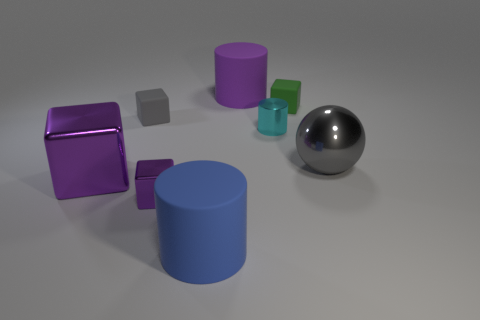Are there any small rubber balls of the same color as the metal cylinder?
Offer a very short reply. No. Are there an equal number of gray rubber things left of the large block and tiny purple things right of the big blue cylinder?
Provide a short and direct response. Yes. Is the shape of the blue rubber object the same as the small matte thing that is to the right of the small purple metal block?
Your answer should be very brief. No. What number of other objects are the same material as the big sphere?
Offer a terse response. 3. Are there any large metallic cubes in front of the blue matte object?
Your answer should be very brief. No. Is the size of the ball the same as the rubber cylinder that is behind the ball?
Make the answer very short. Yes. What color is the large rubber thing that is behind the cylinder in front of the large gray shiny object?
Your response must be concise. Purple. Does the green object have the same size as the metal sphere?
Ensure brevity in your answer.  No. There is a tiny thing that is both behind the cyan thing and left of the small green block; what is its color?
Provide a short and direct response. Gray. What is the size of the green rubber cube?
Provide a succinct answer. Small. 